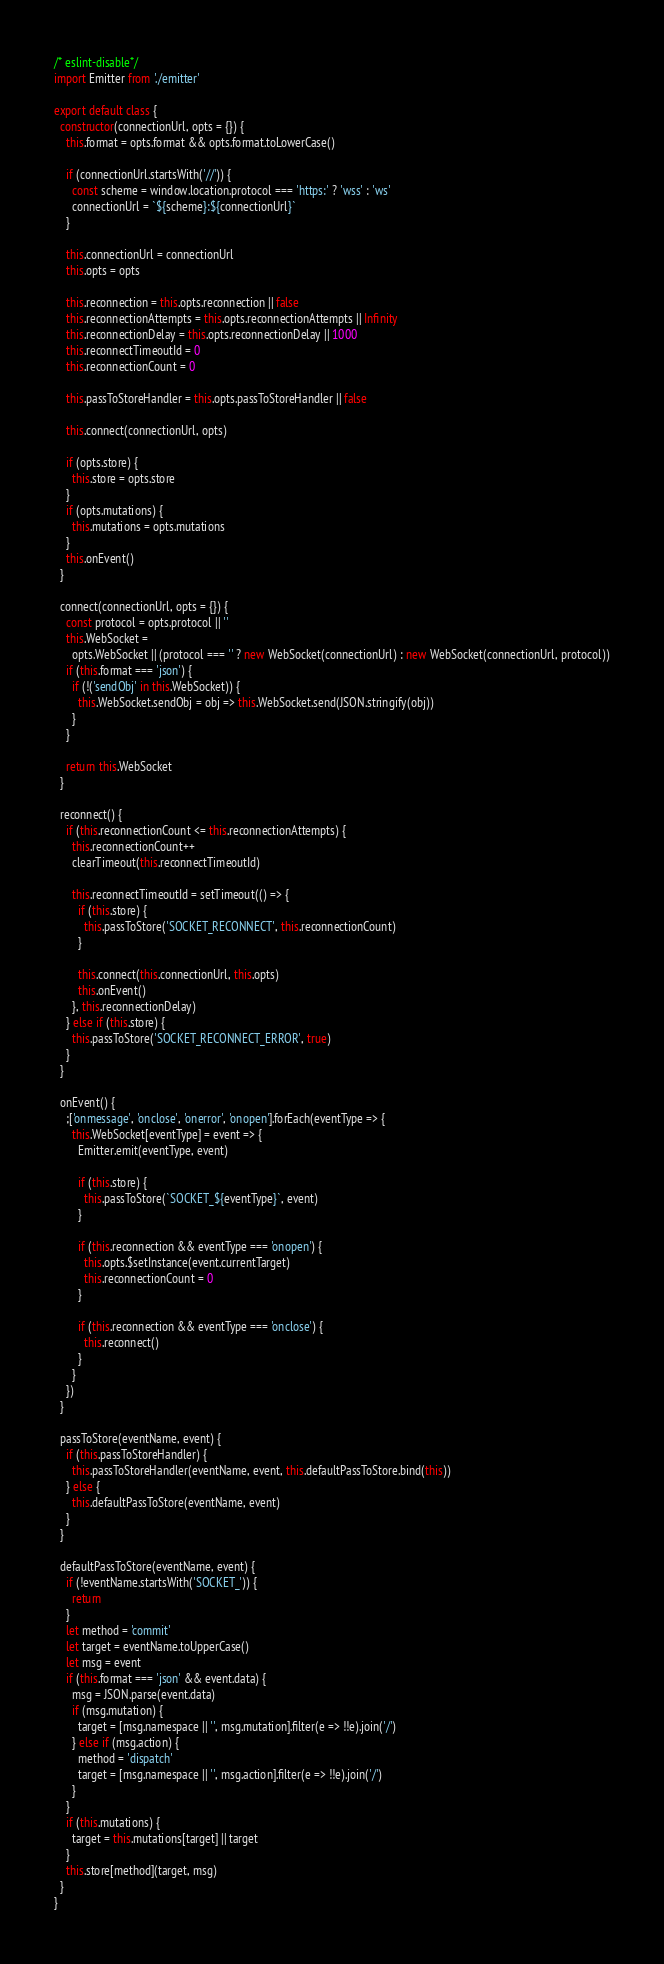Convert code to text. <code><loc_0><loc_0><loc_500><loc_500><_JavaScript_>/* eslint-disable*/
import Emitter from './emitter'

export default class {
  constructor(connectionUrl, opts = {}) {
    this.format = opts.format && opts.format.toLowerCase()

    if (connectionUrl.startsWith('//')) {
      const scheme = window.location.protocol === 'https:' ? 'wss' : 'ws'
      connectionUrl = `${scheme}:${connectionUrl}`
    }

    this.connectionUrl = connectionUrl
    this.opts = opts

    this.reconnection = this.opts.reconnection || false
    this.reconnectionAttempts = this.opts.reconnectionAttempts || Infinity
    this.reconnectionDelay = this.opts.reconnectionDelay || 1000
    this.reconnectTimeoutId = 0
    this.reconnectionCount = 0

    this.passToStoreHandler = this.opts.passToStoreHandler || false

    this.connect(connectionUrl, opts)

    if (opts.store) {
      this.store = opts.store
    }
    if (opts.mutations) {
      this.mutations = opts.mutations
    }
    this.onEvent()
  }

  connect(connectionUrl, opts = {}) {
    const protocol = opts.protocol || ''
    this.WebSocket =
      opts.WebSocket || (protocol === '' ? new WebSocket(connectionUrl) : new WebSocket(connectionUrl, protocol))
    if (this.format === 'json') {
      if (!('sendObj' in this.WebSocket)) {
        this.WebSocket.sendObj = obj => this.WebSocket.send(JSON.stringify(obj))
      }
    }

    return this.WebSocket
  }

  reconnect() {
    if (this.reconnectionCount <= this.reconnectionAttempts) {
      this.reconnectionCount++
      clearTimeout(this.reconnectTimeoutId)

      this.reconnectTimeoutId = setTimeout(() => {
        if (this.store) {
          this.passToStore('SOCKET_RECONNECT', this.reconnectionCount)
        }

        this.connect(this.connectionUrl, this.opts)
        this.onEvent()
      }, this.reconnectionDelay)
    } else if (this.store) {
      this.passToStore('SOCKET_RECONNECT_ERROR', true)
    }
  }

  onEvent() {
    ;['onmessage', 'onclose', 'onerror', 'onopen'].forEach(eventType => {
      this.WebSocket[eventType] = event => {
        Emitter.emit(eventType, event)

        if (this.store) {
          this.passToStore(`SOCKET_${eventType}`, event)
        }

        if (this.reconnection && eventType === 'onopen') {
          this.opts.$setInstance(event.currentTarget)
          this.reconnectionCount = 0
        }

        if (this.reconnection && eventType === 'onclose') {
          this.reconnect()
        }
      }
    })
  }

  passToStore(eventName, event) {
    if (this.passToStoreHandler) {
      this.passToStoreHandler(eventName, event, this.defaultPassToStore.bind(this))
    } else {
      this.defaultPassToStore(eventName, event)
    }
  }

  defaultPassToStore(eventName, event) {
    if (!eventName.startsWith('SOCKET_')) {
      return
    }
    let method = 'commit'
    let target = eventName.toUpperCase()
    let msg = event
    if (this.format === 'json' && event.data) {
      msg = JSON.parse(event.data)
      if (msg.mutation) {
        target = [msg.namespace || '', msg.mutation].filter(e => !!e).join('/')
      } else if (msg.action) {
        method = 'dispatch'
        target = [msg.namespace || '', msg.action].filter(e => !!e).join('/')
      }
    }
    if (this.mutations) {
      target = this.mutations[target] || target
    }
    this.store[method](target, msg)
  }
}
</code> 